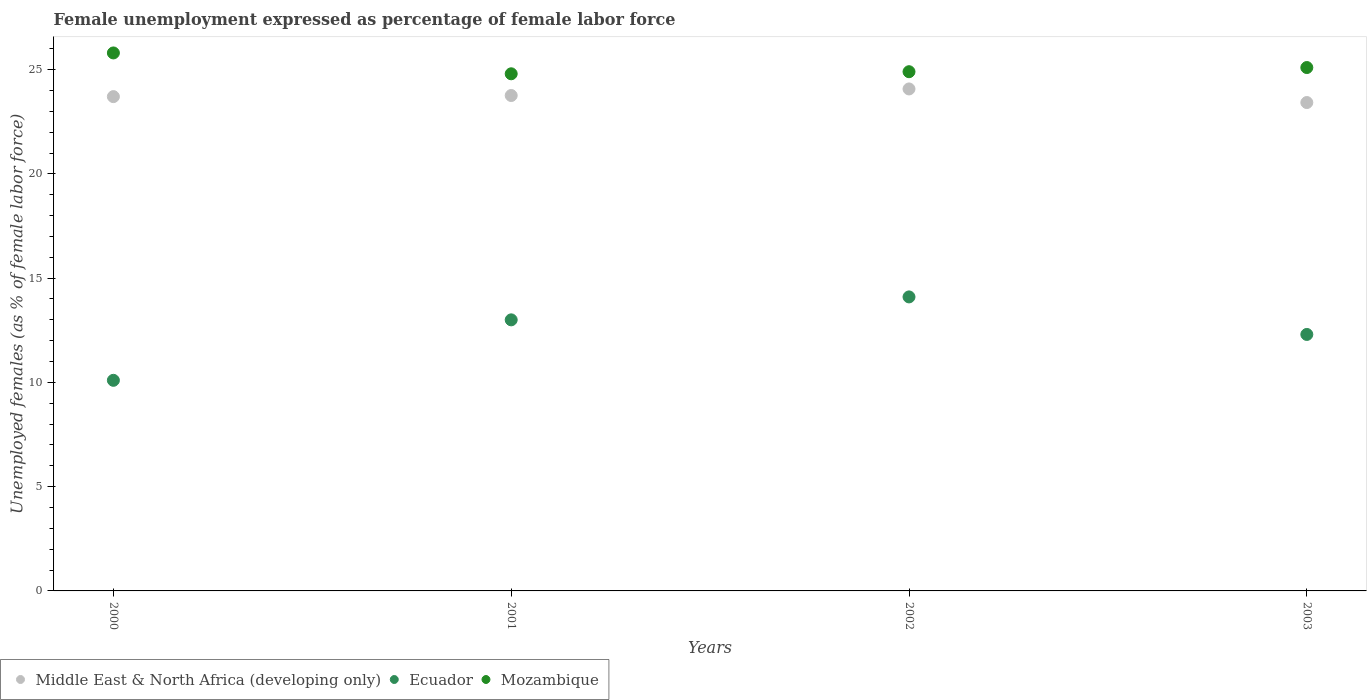What is the unemployment in females in in Mozambique in 2000?
Offer a terse response. 25.8. Across all years, what is the maximum unemployment in females in in Middle East & North Africa (developing only)?
Your answer should be compact. 24.07. Across all years, what is the minimum unemployment in females in in Middle East & North Africa (developing only)?
Give a very brief answer. 23.42. In which year was the unemployment in females in in Ecuador maximum?
Offer a terse response. 2002. In which year was the unemployment in females in in Mozambique minimum?
Provide a succinct answer. 2001. What is the total unemployment in females in in Middle East & North Africa (developing only) in the graph?
Give a very brief answer. 94.96. What is the difference between the unemployment in females in in Ecuador in 2002 and that in 2003?
Offer a terse response. 1.8. What is the difference between the unemployment in females in in Middle East & North Africa (developing only) in 2003 and the unemployment in females in in Ecuador in 2001?
Keep it short and to the point. 10.42. What is the average unemployment in females in in Mozambique per year?
Offer a very short reply. 25.15. In the year 2002, what is the difference between the unemployment in females in in Ecuador and unemployment in females in in Mozambique?
Your response must be concise. -10.8. What is the ratio of the unemployment in females in in Middle East & North Africa (developing only) in 2002 to that in 2003?
Provide a short and direct response. 1.03. Is the unemployment in females in in Middle East & North Africa (developing only) in 2002 less than that in 2003?
Give a very brief answer. No. What is the difference between the highest and the second highest unemployment in females in in Ecuador?
Your answer should be very brief. 1.1. In how many years, is the unemployment in females in in Middle East & North Africa (developing only) greater than the average unemployment in females in in Middle East & North Africa (developing only) taken over all years?
Your answer should be compact. 2. Is it the case that in every year, the sum of the unemployment in females in in Middle East & North Africa (developing only) and unemployment in females in in Ecuador  is greater than the unemployment in females in in Mozambique?
Your answer should be very brief. Yes. Does the unemployment in females in in Middle East & North Africa (developing only) monotonically increase over the years?
Make the answer very short. No. Is the unemployment in females in in Ecuador strictly greater than the unemployment in females in in Mozambique over the years?
Keep it short and to the point. No. Is the unemployment in females in in Ecuador strictly less than the unemployment in females in in Middle East & North Africa (developing only) over the years?
Give a very brief answer. Yes. How many dotlines are there?
Offer a very short reply. 3. What is the difference between two consecutive major ticks on the Y-axis?
Ensure brevity in your answer.  5. Are the values on the major ticks of Y-axis written in scientific E-notation?
Provide a short and direct response. No. Does the graph contain grids?
Offer a very short reply. No. Where does the legend appear in the graph?
Your answer should be compact. Bottom left. How many legend labels are there?
Give a very brief answer. 3. What is the title of the graph?
Make the answer very short. Female unemployment expressed as percentage of female labor force. Does "Seychelles" appear as one of the legend labels in the graph?
Give a very brief answer. No. What is the label or title of the X-axis?
Your answer should be very brief. Years. What is the label or title of the Y-axis?
Provide a short and direct response. Unemployed females (as % of female labor force). What is the Unemployed females (as % of female labor force) of Middle East & North Africa (developing only) in 2000?
Provide a succinct answer. 23.71. What is the Unemployed females (as % of female labor force) of Ecuador in 2000?
Ensure brevity in your answer.  10.1. What is the Unemployed females (as % of female labor force) of Mozambique in 2000?
Offer a very short reply. 25.8. What is the Unemployed females (as % of female labor force) in Middle East & North Africa (developing only) in 2001?
Your answer should be compact. 23.76. What is the Unemployed females (as % of female labor force) in Ecuador in 2001?
Ensure brevity in your answer.  13. What is the Unemployed females (as % of female labor force) of Mozambique in 2001?
Your answer should be compact. 24.8. What is the Unemployed females (as % of female labor force) of Middle East & North Africa (developing only) in 2002?
Your answer should be very brief. 24.07. What is the Unemployed females (as % of female labor force) in Ecuador in 2002?
Offer a very short reply. 14.1. What is the Unemployed females (as % of female labor force) in Mozambique in 2002?
Ensure brevity in your answer.  24.9. What is the Unemployed females (as % of female labor force) in Middle East & North Africa (developing only) in 2003?
Ensure brevity in your answer.  23.42. What is the Unemployed females (as % of female labor force) of Ecuador in 2003?
Your response must be concise. 12.3. What is the Unemployed females (as % of female labor force) of Mozambique in 2003?
Your answer should be compact. 25.1. Across all years, what is the maximum Unemployed females (as % of female labor force) in Middle East & North Africa (developing only)?
Provide a succinct answer. 24.07. Across all years, what is the maximum Unemployed females (as % of female labor force) of Ecuador?
Keep it short and to the point. 14.1. Across all years, what is the maximum Unemployed females (as % of female labor force) of Mozambique?
Provide a succinct answer. 25.8. Across all years, what is the minimum Unemployed females (as % of female labor force) of Middle East & North Africa (developing only)?
Make the answer very short. 23.42. Across all years, what is the minimum Unemployed females (as % of female labor force) in Ecuador?
Your response must be concise. 10.1. Across all years, what is the minimum Unemployed females (as % of female labor force) of Mozambique?
Provide a short and direct response. 24.8. What is the total Unemployed females (as % of female labor force) in Middle East & North Africa (developing only) in the graph?
Provide a short and direct response. 94.96. What is the total Unemployed females (as % of female labor force) in Ecuador in the graph?
Keep it short and to the point. 49.5. What is the total Unemployed females (as % of female labor force) in Mozambique in the graph?
Provide a succinct answer. 100.6. What is the difference between the Unemployed females (as % of female labor force) in Middle East & North Africa (developing only) in 2000 and that in 2001?
Offer a very short reply. -0.05. What is the difference between the Unemployed females (as % of female labor force) of Middle East & North Africa (developing only) in 2000 and that in 2002?
Provide a succinct answer. -0.37. What is the difference between the Unemployed females (as % of female labor force) in Mozambique in 2000 and that in 2002?
Make the answer very short. 0.9. What is the difference between the Unemployed females (as % of female labor force) in Middle East & North Africa (developing only) in 2000 and that in 2003?
Give a very brief answer. 0.28. What is the difference between the Unemployed females (as % of female labor force) in Ecuador in 2000 and that in 2003?
Give a very brief answer. -2.2. What is the difference between the Unemployed females (as % of female labor force) of Middle East & North Africa (developing only) in 2001 and that in 2002?
Offer a very short reply. -0.31. What is the difference between the Unemployed females (as % of female labor force) in Ecuador in 2001 and that in 2002?
Give a very brief answer. -1.1. What is the difference between the Unemployed females (as % of female labor force) of Mozambique in 2001 and that in 2002?
Your answer should be compact. -0.1. What is the difference between the Unemployed females (as % of female labor force) in Middle East & North Africa (developing only) in 2001 and that in 2003?
Keep it short and to the point. 0.34. What is the difference between the Unemployed females (as % of female labor force) of Mozambique in 2001 and that in 2003?
Provide a succinct answer. -0.3. What is the difference between the Unemployed females (as % of female labor force) of Middle East & North Africa (developing only) in 2002 and that in 2003?
Provide a short and direct response. 0.65. What is the difference between the Unemployed females (as % of female labor force) in Ecuador in 2002 and that in 2003?
Your answer should be compact. 1.8. What is the difference between the Unemployed females (as % of female labor force) in Middle East & North Africa (developing only) in 2000 and the Unemployed females (as % of female labor force) in Ecuador in 2001?
Your answer should be very brief. 10.71. What is the difference between the Unemployed females (as % of female labor force) in Middle East & North Africa (developing only) in 2000 and the Unemployed females (as % of female labor force) in Mozambique in 2001?
Your response must be concise. -1.09. What is the difference between the Unemployed females (as % of female labor force) in Ecuador in 2000 and the Unemployed females (as % of female labor force) in Mozambique in 2001?
Make the answer very short. -14.7. What is the difference between the Unemployed females (as % of female labor force) in Middle East & North Africa (developing only) in 2000 and the Unemployed females (as % of female labor force) in Ecuador in 2002?
Keep it short and to the point. 9.61. What is the difference between the Unemployed females (as % of female labor force) in Middle East & North Africa (developing only) in 2000 and the Unemployed females (as % of female labor force) in Mozambique in 2002?
Give a very brief answer. -1.19. What is the difference between the Unemployed females (as % of female labor force) of Ecuador in 2000 and the Unemployed females (as % of female labor force) of Mozambique in 2002?
Give a very brief answer. -14.8. What is the difference between the Unemployed females (as % of female labor force) of Middle East & North Africa (developing only) in 2000 and the Unemployed females (as % of female labor force) of Ecuador in 2003?
Ensure brevity in your answer.  11.41. What is the difference between the Unemployed females (as % of female labor force) in Middle East & North Africa (developing only) in 2000 and the Unemployed females (as % of female labor force) in Mozambique in 2003?
Your response must be concise. -1.39. What is the difference between the Unemployed females (as % of female labor force) in Middle East & North Africa (developing only) in 2001 and the Unemployed females (as % of female labor force) in Ecuador in 2002?
Your answer should be compact. 9.66. What is the difference between the Unemployed females (as % of female labor force) of Middle East & North Africa (developing only) in 2001 and the Unemployed females (as % of female labor force) of Mozambique in 2002?
Offer a terse response. -1.14. What is the difference between the Unemployed females (as % of female labor force) of Middle East & North Africa (developing only) in 2001 and the Unemployed females (as % of female labor force) of Ecuador in 2003?
Provide a short and direct response. 11.46. What is the difference between the Unemployed females (as % of female labor force) of Middle East & North Africa (developing only) in 2001 and the Unemployed females (as % of female labor force) of Mozambique in 2003?
Give a very brief answer. -1.34. What is the difference between the Unemployed females (as % of female labor force) in Ecuador in 2001 and the Unemployed females (as % of female labor force) in Mozambique in 2003?
Your answer should be compact. -12.1. What is the difference between the Unemployed females (as % of female labor force) in Middle East & North Africa (developing only) in 2002 and the Unemployed females (as % of female labor force) in Ecuador in 2003?
Provide a succinct answer. 11.77. What is the difference between the Unemployed females (as % of female labor force) of Middle East & North Africa (developing only) in 2002 and the Unemployed females (as % of female labor force) of Mozambique in 2003?
Provide a short and direct response. -1.03. What is the average Unemployed females (as % of female labor force) of Middle East & North Africa (developing only) per year?
Offer a terse response. 23.74. What is the average Unemployed females (as % of female labor force) of Ecuador per year?
Give a very brief answer. 12.38. What is the average Unemployed females (as % of female labor force) in Mozambique per year?
Provide a succinct answer. 25.15. In the year 2000, what is the difference between the Unemployed females (as % of female labor force) of Middle East & North Africa (developing only) and Unemployed females (as % of female labor force) of Ecuador?
Ensure brevity in your answer.  13.61. In the year 2000, what is the difference between the Unemployed females (as % of female labor force) in Middle East & North Africa (developing only) and Unemployed females (as % of female labor force) in Mozambique?
Give a very brief answer. -2.09. In the year 2000, what is the difference between the Unemployed females (as % of female labor force) of Ecuador and Unemployed females (as % of female labor force) of Mozambique?
Provide a succinct answer. -15.7. In the year 2001, what is the difference between the Unemployed females (as % of female labor force) in Middle East & North Africa (developing only) and Unemployed females (as % of female labor force) in Ecuador?
Provide a succinct answer. 10.76. In the year 2001, what is the difference between the Unemployed females (as % of female labor force) in Middle East & North Africa (developing only) and Unemployed females (as % of female labor force) in Mozambique?
Offer a terse response. -1.04. In the year 2001, what is the difference between the Unemployed females (as % of female labor force) in Ecuador and Unemployed females (as % of female labor force) in Mozambique?
Provide a succinct answer. -11.8. In the year 2002, what is the difference between the Unemployed females (as % of female labor force) of Middle East & North Africa (developing only) and Unemployed females (as % of female labor force) of Ecuador?
Provide a succinct answer. 9.97. In the year 2002, what is the difference between the Unemployed females (as % of female labor force) of Middle East & North Africa (developing only) and Unemployed females (as % of female labor force) of Mozambique?
Keep it short and to the point. -0.83. In the year 2003, what is the difference between the Unemployed females (as % of female labor force) in Middle East & North Africa (developing only) and Unemployed females (as % of female labor force) in Ecuador?
Your response must be concise. 11.12. In the year 2003, what is the difference between the Unemployed females (as % of female labor force) of Middle East & North Africa (developing only) and Unemployed females (as % of female labor force) of Mozambique?
Your answer should be compact. -1.68. In the year 2003, what is the difference between the Unemployed females (as % of female labor force) in Ecuador and Unemployed females (as % of female labor force) in Mozambique?
Your answer should be compact. -12.8. What is the ratio of the Unemployed females (as % of female labor force) of Middle East & North Africa (developing only) in 2000 to that in 2001?
Ensure brevity in your answer.  1. What is the ratio of the Unemployed females (as % of female labor force) in Ecuador in 2000 to that in 2001?
Keep it short and to the point. 0.78. What is the ratio of the Unemployed females (as % of female labor force) in Mozambique in 2000 to that in 2001?
Give a very brief answer. 1.04. What is the ratio of the Unemployed females (as % of female labor force) of Middle East & North Africa (developing only) in 2000 to that in 2002?
Provide a succinct answer. 0.98. What is the ratio of the Unemployed females (as % of female labor force) in Ecuador in 2000 to that in 2002?
Make the answer very short. 0.72. What is the ratio of the Unemployed females (as % of female labor force) of Mozambique in 2000 to that in 2002?
Ensure brevity in your answer.  1.04. What is the ratio of the Unemployed females (as % of female labor force) in Middle East & North Africa (developing only) in 2000 to that in 2003?
Provide a short and direct response. 1.01. What is the ratio of the Unemployed females (as % of female labor force) in Ecuador in 2000 to that in 2003?
Give a very brief answer. 0.82. What is the ratio of the Unemployed females (as % of female labor force) of Mozambique in 2000 to that in 2003?
Your answer should be compact. 1.03. What is the ratio of the Unemployed females (as % of female labor force) of Middle East & North Africa (developing only) in 2001 to that in 2002?
Your response must be concise. 0.99. What is the ratio of the Unemployed females (as % of female labor force) of Ecuador in 2001 to that in 2002?
Your answer should be compact. 0.92. What is the ratio of the Unemployed females (as % of female labor force) in Middle East & North Africa (developing only) in 2001 to that in 2003?
Ensure brevity in your answer.  1.01. What is the ratio of the Unemployed females (as % of female labor force) in Ecuador in 2001 to that in 2003?
Your answer should be compact. 1.06. What is the ratio of the Unemployed females (as % of female labor force) in Middle East & North Africa (developing only) in 2002 to that in 2003?
Keep it short and to the point. 1.03. What is the ratio of the Unemployed females (as % of female labor force) in Ecuador in 2002 to that in 2003?
Keep it short and to the point. 1.15. What is the ratio of the Unemployed females (as % of female labor force) in Mozambique in 2002 to that in 2003?
Your answer should be compact. 0.99. What is the difference between the highest and the second highest Unemployed females (as % of female labor force) of Middle East & North Africa (developing only)?
Your response must be concise. 0.31. What is the difference between the highest and the second highest Unemployed females (as % of female labor force) in Mozambique?
Provide a succinct answer. 0.7. What is the difference between the highest and the lowest Unemployed females (as % of female labor force) in Middle East & North Africa (developing only)?
Your answer should be very brief. 0.65. What is the difference between the highest and the lowest Unemployed females (as % of female labor force) in Ecuador?
Provide a succinct answer. 4. 